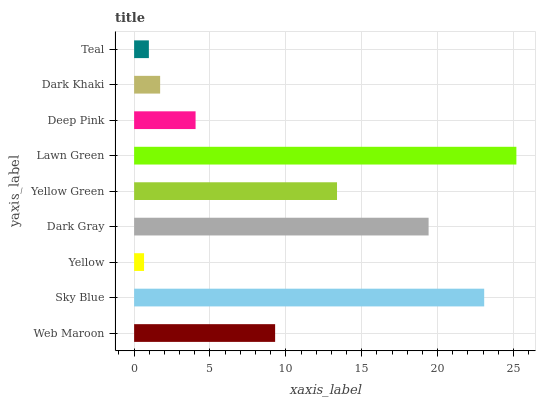Is Yellow the minimum?
Answer yes or no. Yes. Is Lawn Green the maximum?
Answer yes or no. Yes. Is Sky Blue the minimum?
Answer yes or no. No. Is Sky Blue the maximum?
Answer yes or no. No. Is Sky Blue greater than Web Maroon?
Answer yes or no. Yes. Is Web Maroon less than Sky Blue?
Answer yes or no. Yes. Is Web Maroon greater than Sky Blue?
Answer yes or no. No. Is Sky Blue less than Web Maroon?
Answer yes or no. No. Is Web Maroon the high median?
Answer yes or no. Yes. Is Web Maroon the low median?
Answer yes or no. Yes. Is Dark Gray the high median?
Answer yes or no. No. Is Dark Gray the low median?
Answer yes or no. No. 